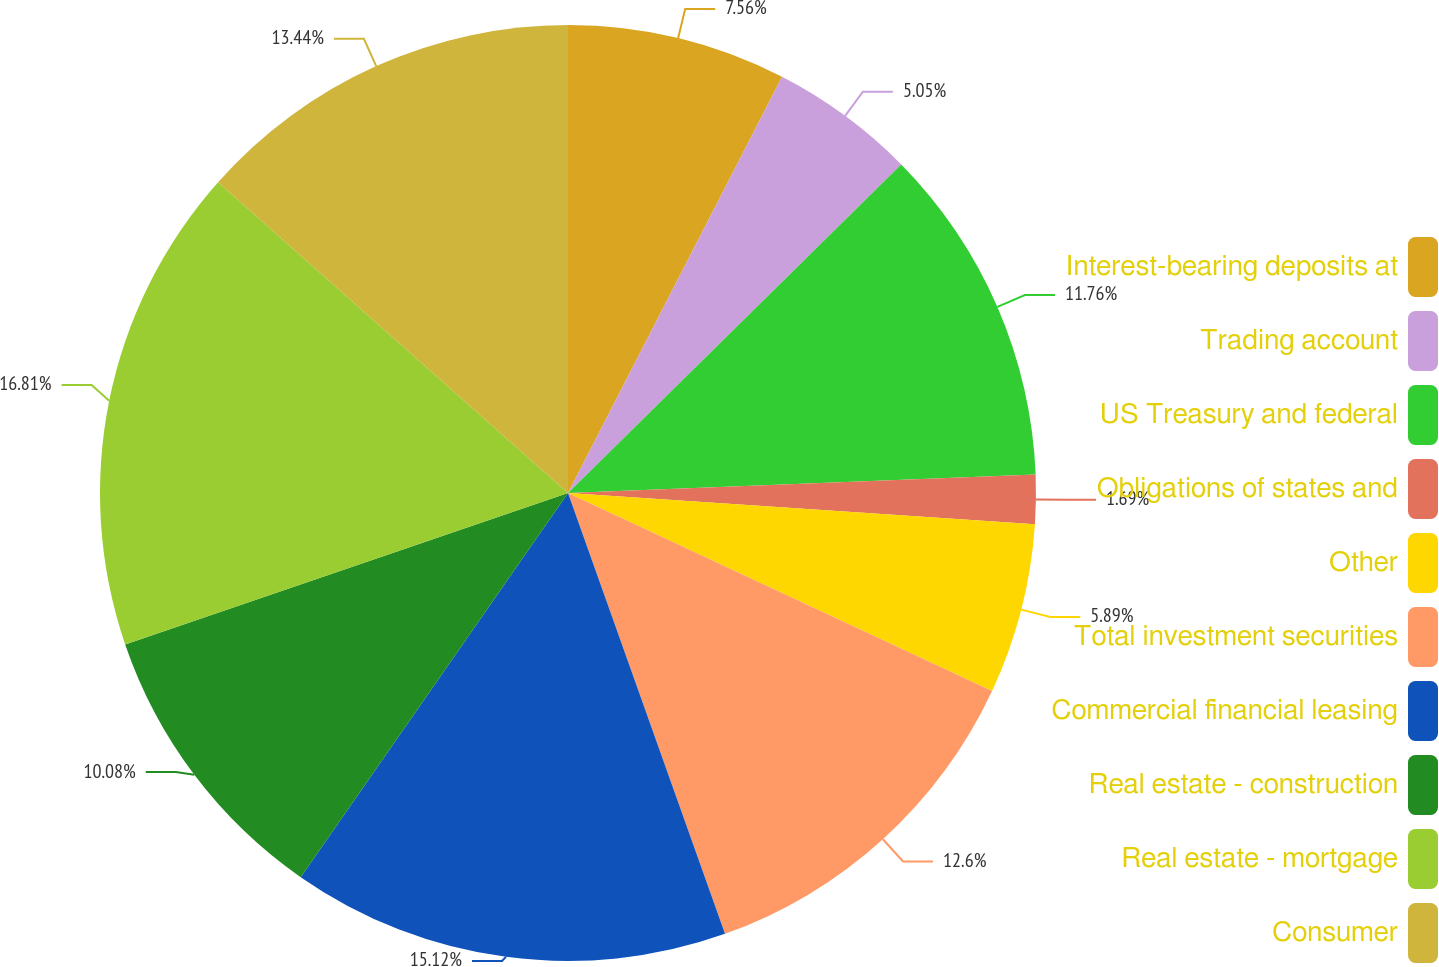Convert chart. <chart><loc_0><loc_0><loc_500><loc_500><pie_chart><fcel>Interest-bearing deposits at<fcel>Trading account<fcel>US Treasury and federal<fcel>Obligations of states and<fcel>Other<fcel>Total investment securities<fcel>Commercial financial leasing<fcel>Real estate - construction<fcel>Real estate - mortgage<fcel>Consumer<nl><fcel>7.56%<fcel>5.05%<fcel>11.76%<fcel>1.69%<fcel>5.89%<fcel>12.6%<fcel>15.12%<fcel>10.08%<fcel>16.8%<fcel>13.44%<nl></chart> 